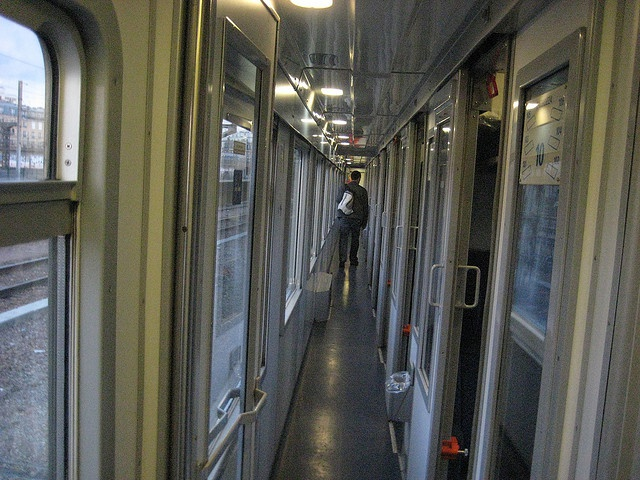Describe the objects in this image and their specific colors. I can see people in maroon, black, gray, darkgray, and lightgray tones and backpack in maroon, gray, black, darkgray, and lightgray tones in this image. 